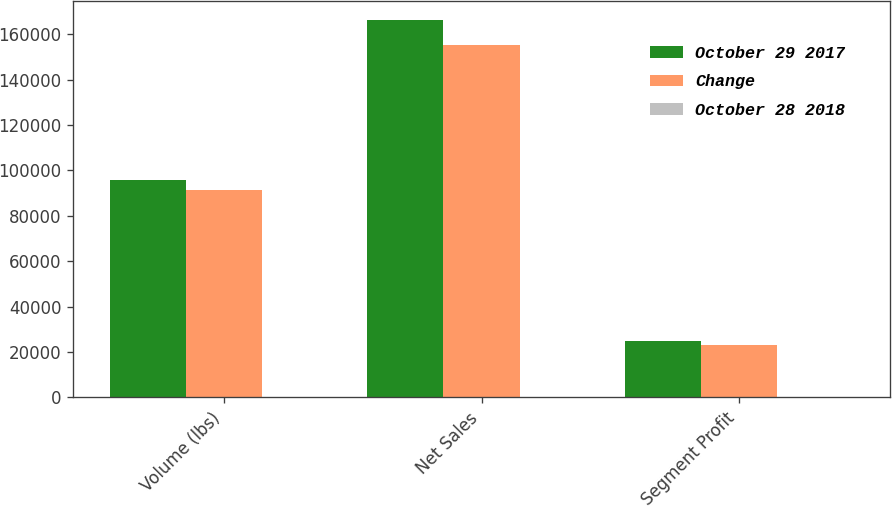Convert chart. <chart><loc_0><loc_0><loc_500><loc_500><stacked_bar_chart><ecel><fcel>Volume (lbs)<fcel>Net Sales<fcel>Segment Profit<nl><fcel>October 29 2017<fcel>95600<fcel>166391<fcel>24802<nl><fcel>Change<fcel>91414<fcel>155130<fcel>23113<nl><fcel>October 28 2018<fcel>4.6<fcel>7.3<fcel>7.3<nl></chart> 